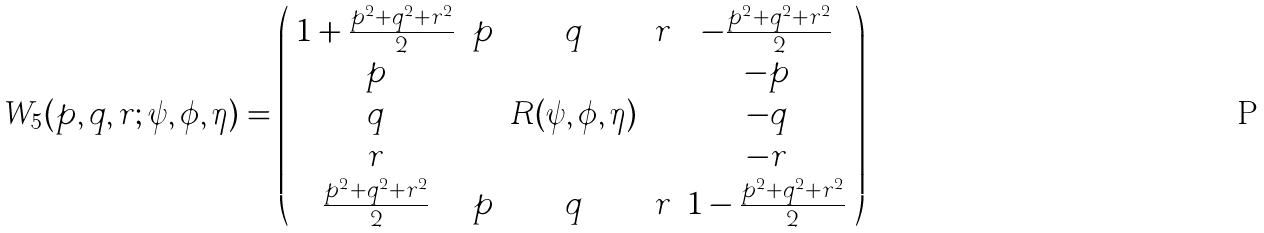<formula> <loc_0><loc_0><loc_500><loc_500>W _ { 5 } ( p , q , r ; \psi , \phi , \eta ) = \left ( \begin{array} { c c c c c } 1 + \frac { p ^ { 2 } + q ^ { 2 } + r ^ { 2 } } { 2 } & p & q & r & - \frac { p ^ { 2 } + q ^ { 2 } + r ^ { 2 } } { 2 } \\ p & & & & - p \\ q & & R ( \psi , \phi , \eta ) & & - q \\ r & & & & - r \\ \frac { p ^ { 2 } + q ^ { 2 } + r ^ { 2 } } { 2 } & p & q & r & 1 - \frac { p ^ { 2 } + q ^ { 2 } + r ^ { 2 } } { 2 } \end{array} \right )</formula> 